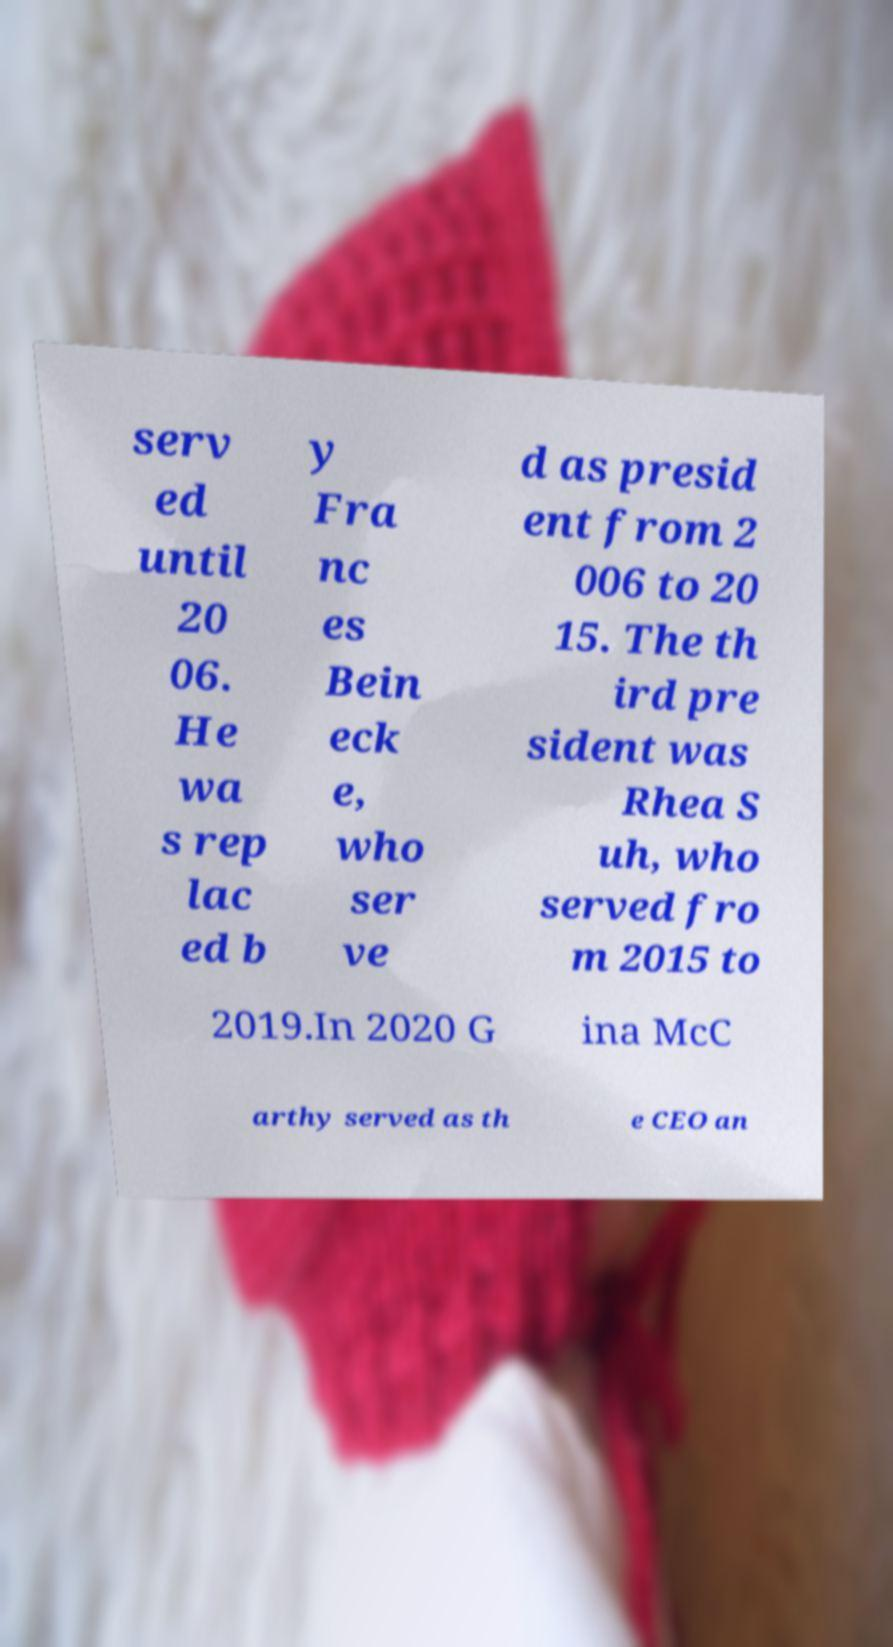Could you extract and type out the text from this image? serv ed until 20 06. He wa s rep lac ed b y Fra nc es Bein eck e, who ser ve d as presid ent from 2 006 to 20 15. The th ird pre sident was Rhea S uh, who served fro m 2015 to 2019.In 2020 G ina McC arthy served as th e CEO an 